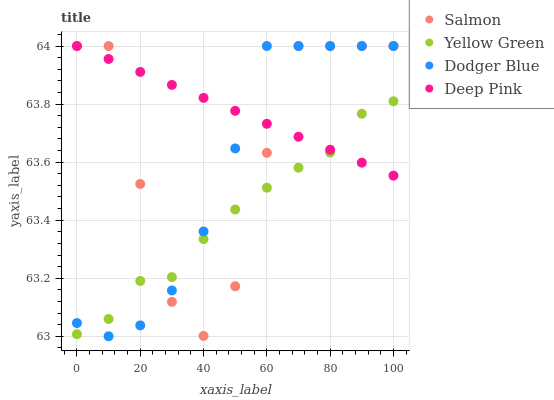Does Yellow Green have the minimum area under the curve?
Answer yes or no. Yes. Does Deep Pink have the maximum area under the curve?
Answer yes or no. Yes. Does Salmon have the minimum area under the curve?
Answer yes or no. No. Does Salmon have the maximum area under the curve?
Answer yes or no. No. Is Deep Pink the smoothest?
Answer yes or no. Yes. Is Salmon the roughest?
Answer yes or no. Yes. Is Salmon the smoothest?
Answer yes or no. No. Is Deep Pink the roughest?
Answer yes or no. No. Does Dodger Blue have the lowest value?
Answer yes or no. Yes. Does Salmon have the lowest value?
Answer yes or no. No. Does Salmon have the highest value?
Answer yes or no. Yes. Does Yellow Green have the highest value?
Answer yes or no. No. Does Dodger Blue intersect Salmon?
Answer yes or no. Yes. Is Dodger Blue less than Salmon?
Answer yes or no. No. Is Dodger Blue greater than Salmon?
Answer yes or no. No. 